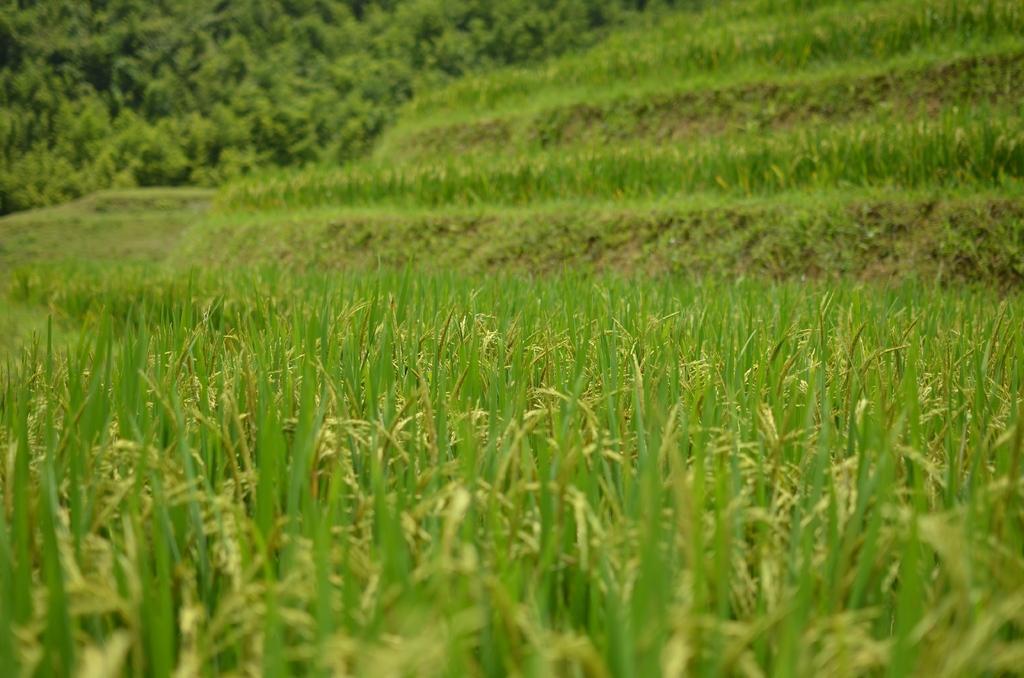Can you describe this image briefly? In this picture, we can see green plants and trees. 